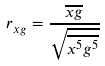<formula> <loc_0><loc_0><loc_500><loc_500>r _ { x g } = \frac { \overline { x g } } { \sqrt { \overline { x ^ { 5 } } \overline { g ^ { 5 } } } }</formula> 